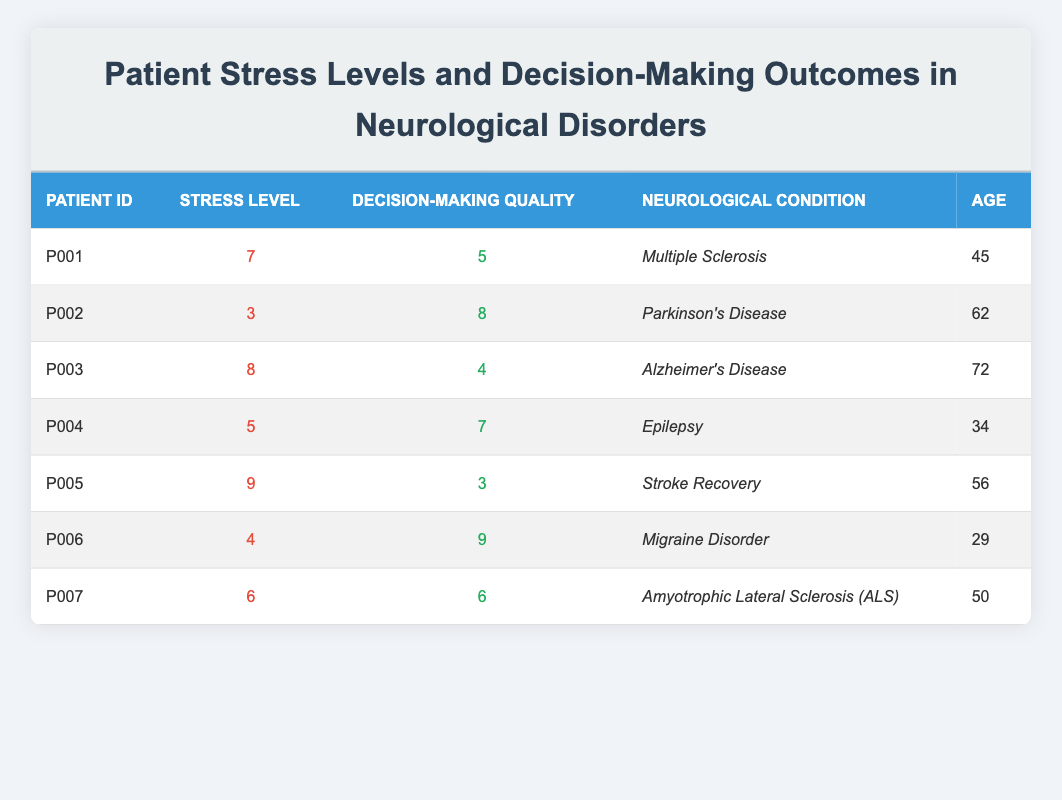What is the stress level of patient P002? By referring to the table, we see that patient P002 has a stress level of 3.
Answer: 3 Which patient has the highest decision-making quality? In the table, patient P006 has the highest decision-making quality with a score of 9.
Answer: P006 What is the average stress level of all patients? We sum the stress levels: 7 + 3 + 8 + 5 + 9 + 4 + 6 = 42, and then divide by 7 (the number of patients): 42 / 7 = 6.
Answer: 6 Is the decision-making quality of patient P005 greater than 5? By checking the table, patient P005 has a decision-making quality of 3, which is not greater than 5.
Answer: No Which neurological condition corresponds to the lowest stress level and what is that level? The lowest stress level noted in the table is 3, which corresponds to Parkinson's Disease in patient P002.
Answer: Parkinson's Disease, 3 What is the relationship between stress level and decision-making quality in patients in terms of their scores? If we analyze the data, there seems to be a negative correlation; as stress levels increase, decision-making quality tends to decrease. For instance, patient P005 (stress level 9) has decision-making quality 3, whereas patient P002 (stress level 3) has quality 8.
Answer: Negative correlation How many patients have a stress level above 6? By examining the stress levels, we see that patients P001 (7), P003 (8), and P005 (9) have stress levels above 6. Thus, there are 3 patients.
Answer: 3 Is the age of patient P004 over 40? Looking at the table, patient P004 is 34 years old, which is not over 40.
Answer: No 